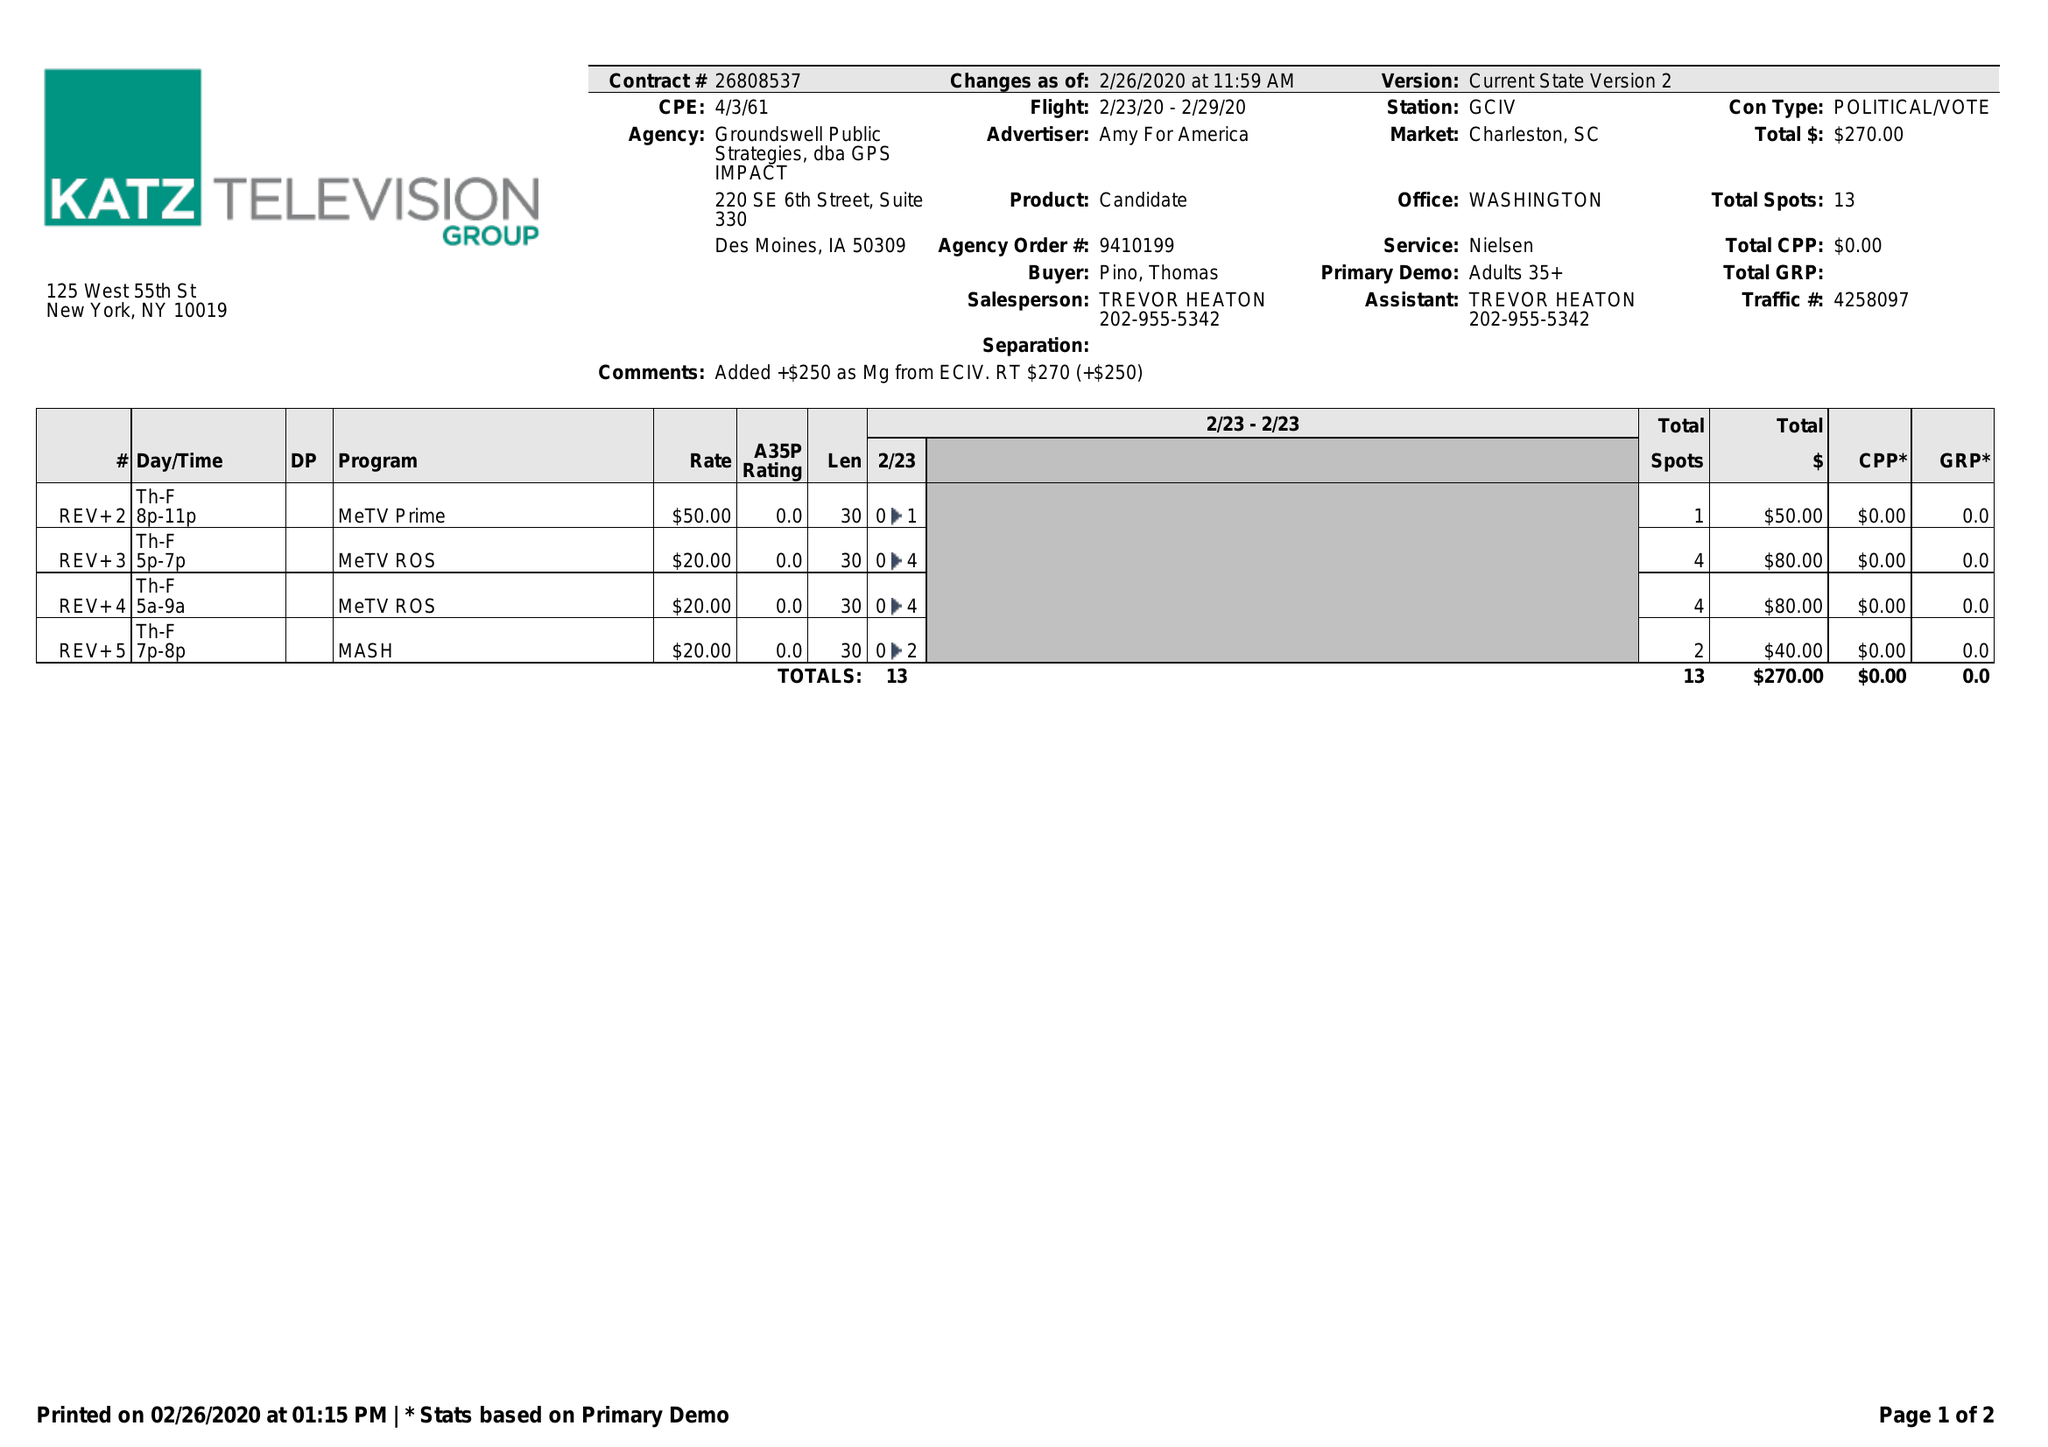What is the value for the flight_from?
Answer the question using a single word or phrase. 02/23/20 